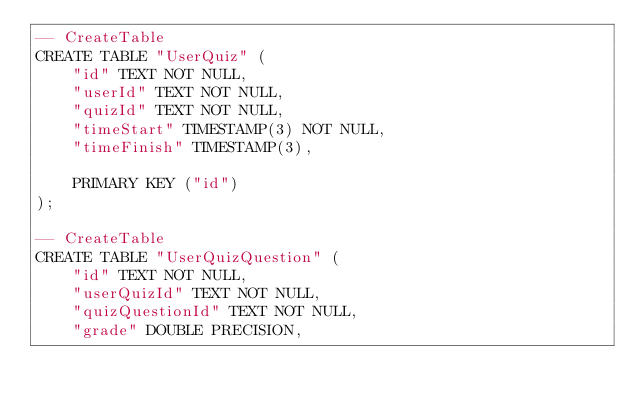<code> <loc_0><loc_0><loc_500><loc_500><_SQL_>-- CreateTable
CREATE TABLE "UserQuiz" (
    "id" TEXT NOT NULL,
    "userId" TEXT NOT NULL,
    "quizId" TEXT NOT NULL,
    "timeStart" TIMESTAMP(3) NOT NULL,
    "timeFinish" TIMESTAMP(3),

    PRIMARY KEY ("id")
);

-- CreateTable
CREATE TABLE "UserQuizQuestion" (
    "id" TEXT NOT NULL,
    "userQuizId" TEXT NOT NULL,
    "quizQuestionId" TEXT NOT NULL,
    "grade" DOUBLE PRECISION,
</code> 